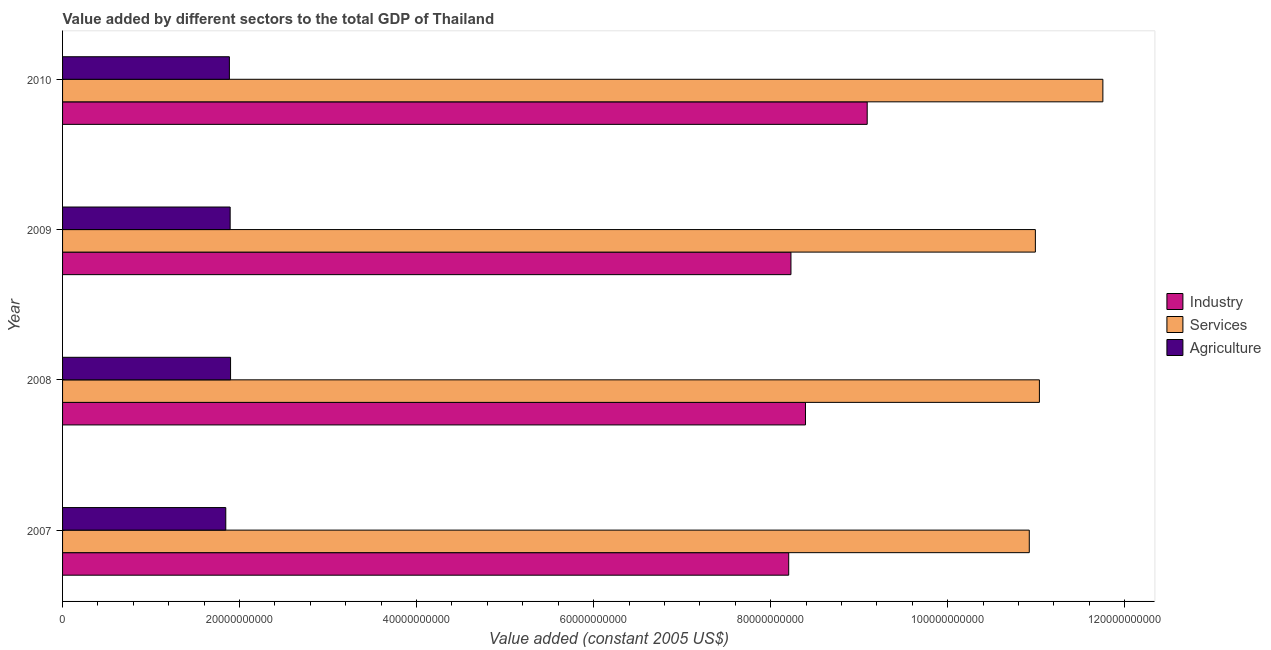How many groups of bars are there?
Keep it short and to the point. 4. What is the label of the 4th group of bars from the top?
Give a very brief answer. 2007. In how many cases, is the number of bars for a given year not equal to the number of legend labels?
Your answer should be compact. 0. What is the value added by services in 2009?
Your answer should be very brief. 1.10e+11. Across all years, what is the maximum value added by agricultural sector?
Your response must be concise. 1.90e+1. Across all years, what is the minimum value added by agricultural sector?
Provide a succinct answer. 1.84e+1. In which year was the value added by agricultural sector maximum?
Keep it short and to the point. 2008. What is the total value added by industrial sector in the graph?
Your answer should be compact. 3.39e+11. What is the difference between the value added by agricultural sector in 2007 and that in 2010?
Your response must be concise. -4.08e+08. What is the difference between the value added by services in 2007 and the value added by agricultural sector in 2008?
Give a very brief answer. 9.02e+1. What is the average value added by agricultural sector per year?
Offer a terse response. 1.88e+1. In the year 2009, what is the difference between the value added by agricultural sector and value added by services?
Your answer should be compact. -9.10e+1. In how many years, is the value added by agricultural sector greater than 116000000000 US$?
Make the answer very short. 0. What is the ratio of the value added by agricultural sector in 2008 to that in 2009?
Give a very brief answer. 1. Is the value added by services in 2008 less than that in 2010?
Keep it short and to the point. Yes. Is the difference between the value added by services in 2007 and 2008 greater than the difference between the value added by agricultural sector in 2007 and 2008?
Offer a terse response. No. What is the difference between the highest and the second highest value added by services?
Provide a succinct answer. 7.17e+09. What is the difference between the highest and the lowest value added by industrial sector?
Offer a very short reply. 8.87e+09. Is the sum of the value added by services in 2007 and 2009 greater than the maximum value added by agricultural sector across all years?
Provide a succinct answer. Yes. What does the 3rd bar from the top in 2009 represents?
Make the answer very short. Industry. What does the 2nd bar from the bottom in 2010 represents?
Your answer should be very brief. Services. Is it the case that in every year, the sum of the value added by industrial sector and value added by services is greater than the value added by agricultural sector?
Your answer should be compact. Yes. How many bars are there?
Offer a terse response. 12. What is the difference between two consecutive major ticks on the X-axis?
Ensure brevity in your answer.  2.00e+1. Are the values on the major ticks of X-axis written in scientific E-notation?
Make the answer very short. No. Does the graph contain any zero values?
Provide a short and direct response. No. Does the graph contain grids?
Your response must be concise. No. Where does the legend appear in the graph?
Offer a terse response. Center right. How are the legend labels stacked?
Make the answer very short. Vertical. What is the title of the graph?
Make the answer very short. Value added by different sectors to the total GDP of Thailand. What is the label or title of the X-axis?
Offer a terse response. Value added (constant 2005 US$). What is the Value added (constant 2005 US$) of Industry in 2007?
Your answer should be compact. 8.20e+1. What is the Value added (constant 2005 US$) in Services in 2007?
Your answer should be compact. 1.09e+11. What is the Value added (constant 2005 US$) in Agriculture in 2007?
Give a very brief answer. 1.84e+1. What is the Value added (constant 2005 US$) in Industry in 2008?
Your answer should be very brief. 8.39e+1. What is the Value added (constant 2005 US$) in Services in 2008?
Keep it short and to the point. 1.10e+11. What is the Value added (constant 2005 US$) in Agriculture in 2008?
Offer a terse response. 1.90e+1. What is the Value added (constant 2005 US$) of Industry in 2009?
Offer a very short reply. 8.23e+1. What is the Value added (constant 2005 US$) in Services in 2009?
Offer a terse response. 1.10e+11. What is the Value added (constant 2005 US$) in Agriculture in 2009?
Ensure brevity in your answer.  1.89e+1. What is the Value added (constant 2005 US$) of Industry in 2010?
Your response must be concise. 9.09e+1. What is the Value added (constant 2005 US$) in Services in 2010?
Ensure brevity in your answer.  1.18e+11. What is the Value added (constant 2005 US$) of Agriculture in 2010?
Your response must be concise. 1.88e+1. Across all years, what is the maximum Value added (constant 2005 US$) of Industry?
Offer a terse response. 9.09e+1. Across all years, what is the maximum Value added (constant 2005 US$) in Services?
Your response must be concise. 1.18e+11. Across all years, what is the maximum Value added (constant 2005 US$) in Agriculture?
Your answer should be very brief. 1.90e+1. Across all years, what is the minimum Value added (constant 2005 US$) of Industry?
Your response must be concise. 8.20e+1. Across all years, what is the minimum Value added (constant 2005 US$) in Services?
Offer a terse response. 1.09e+11. Across all years, what is the minimum Value added (constant 2005 US$) in Agriculture?
Make the answer very short. 1.84e+1. What is the total Value added (constant 2005 US$) of Industry in the graph?
Ensure brevity in your answer.  3.39e+11. What is the total Value added (constant 2005 US$) of Services in the graph?
Keep it short and to the point. 4.47e+11. What is the total Value added (constant 2005 US$) of Agriculture in the graph?
Give a very brief answer. 7.52e+1. What is the difference between the Value added (constant 2005 US$) of Industry in 2007 and that in 2008?
Your response must be concise. -1.90e+09. What is the difference between the Value added (constant 2005 US$) in Services in 2007 and that in 2008?
Offer a very short reply. -1.14e+09. What is the difference between the Value added (constant 2005 US$) of Agriculture in 2007 and that in 2008?
Your answer should be compact. -5.41e+08. What is the difference between the Value added (constant 2005 US$) in Industry in 2007 and that in 2009?
Provide a short and direct response. -2.54e+08. What is the difference between the Value added (constant 2005 US$) in Services in 2007 and that in 2009?
Ensure brevity in your answer.  -6.89e+08. What is the difference between the Value added (constant 2005 US$) of Agriculture in 2007 and that in 2009?
Give a very brief answer. -4.95e+08. What is the difference between the Value added (constant 2005 US$) of Industry in 2007 and that in 2010?
Give a very brief answer. -8.87e+09. What is the difference between the Value added (constant 2005 US$) in Services in 2007 and that in 2010?
Give a very brief answer. -8.32e+09. What is the difference between the Value added (constant 2005 US$) in Agriculture in 2007 and that in 2010?
Keep it short and to the point. -4.08e+08. What is the difference between the Value added (constant 2005 US$) in Industry in 2008 and that in 2009?
Keep it short and to the point. 1.64e+09. What is the difference between the Value added (constant 2005 US$) in Services in 2008 and that in 2009?
Keep it short and to the point. 4.55e+08. What is the difference between the Value added (constant 2005 US$) in Agriculture in 2008 and that in 2009?
Ensure brevity in your answer.  4.60e+07. What is the difference between the Value added (constant 2005 US$) in Industry in 2008 and that in 2010?
Make the answer very short. -6.97e+09. What is the difference between the Value added (constant 2005 US$) in Services in 2008 and that in 2010?
Offer a terse response. -7.17e+09. What is the difference between the Value added (constant 2005 US$) in Agriculture in 2008 and that in 2010?
Offer a very short reply. 1.33e+08. What is the difference between the Value added (constant 2005 US$) in Industry in 2009 and that in 2010?
Offer a very short reply. -8.62e+09. What is the difference between the Value added (constant 2005 US$) in Services in 2009 and that in 2010?
Your answer should be compact. -7.63e+09. What is the difference between the Value added (constant 2005 US$) of Agriculture in 2009 and that in 2010?
Your answer should be very brief. 8.66e+07. What is the difference between the Value added (constant 2005 US$) of Industry in 2007 and the Value added (constant 2005 US$) of Services in 2008?
Your answer should be very brief. -2.83e+1. What is the difference between the Value added (constant 2005 US$) of Industry in 2007 and the Value added (constant 2005 US$) of Agriculture in 2008?
Provide a succinct answer. 6.31e+1. What is the difference between the Value added (constant 2005 US$) in Services in 2007 and the Value added (constant 2005 US$) in Agriculture in 2008?
Your answer should be very brief. 9.02e+1. What is the difference between the Value added (constant 2005 US$) in Industry in 2007 and the Value added (constant 2005 US$) in Services in 2009?
Provide a short and direct response. -2.79e+1. What is the difference between the Value added (constant 2005 US$) of Industry in 2007 and the Value added (constant 2005 US$) of Agriculture in 2009?
Offer a very short reply. 6.31e+1. What is the difference between the Value added (constant 2005 US$) in Services in 2007 and the Value added (constant 2005 US$) in Agriculture in 2009?
Make the answer very short. 9.03e+1. What is the difference between the Value added (constant 2005 US$) of Industry in 2007 and the Value added (constant 2005 US$) of Services in 2010?
Ensure brevity in your answer.  -3.55e+1. What is the difference between the Value added (constant 2005 US$) in Industry in 2007 and the Value added (constant 2005 US$) in Agriculture in 2010?
Provide a short and direct response. 6.32e+1. What is the difference between the Value added (constant 2005 US$) in Services in 2007 and the Value added (constant 2005 US$) in Agriculture in 2010?
Your answer should be very brief. 9.04e+1. What is the difference between the Value added (constant 2005 US$) in Industry in 2008 and the Value added (constant 2005 US$) in Services in 2009?
Provide a succinct answer. -2.60e+1. What is the difference between the Value added (constant 2005 US$) of Industry in 2008 and the Value added (constant 2005 US$) of Agriculture in 2009?
Give a very brief answer. 6.50e+1. What is the difference between the Value added (constant 2005 US$) in Services in 2008 and the Value added (constant 2005 US$) in Agriculture in 2009?
Your answer should be very brief. 9.14e+1. What is the difference between the Value added (constant 2005 US$) in Industry in 2008 and the Value added (constant 2005 US$) in Services in 2010?
Make the answer very short. -3.36e+1. What is the difference between the Value added (constant 2005 US$) of Industry in 2008 and the Value added (constant 2005 US$) of Agriculture in 2010?
Offer a very short reply. 6.51e+1. What is the difference between the Value added (constant 2005 US$) of Services in 2008 and the Value added (constant 2005 US$) of Agriculture in 2010?
Your answer should be very brief. 9.15e+1. What is the difference between the Value added (constant 2005 US$) in Industry in 2009 and the Value added (constant 2005 US$) in Services in 2010?
Your answer should be compact. -3.52e+1. What is the difference between the Value added (constant 2005 US$) of Industry in 2009 and the Value added (constant 2005 US$) of Agriculture in 2010?
Your answer should be very brief. 6.34e+1. What is the difference between the Value added (constant 2005 US$) in Services in 2009 and the Value added (constant 2005 US$) in Agriculture in 2010?
Ensure brevity in your answer.  9.11e+1. What is the average Value added (constant 2005 US$) of Industry per year?
Provide a short and direct response. 8.48e+1. What is the average Value added (constant 2005 US$) of Services per year?
Your response must be concise. 1.12e+11. What is the average Value added (constant 2005 US$) in Agriculture per year?
Offer a terse response. 1.88e+1. In the year 2007, what is the difference between the Value added (constant 2005 US$) of Industry and Value added (constant 2005 US$) of Services?
Provide a short and direct response. -2.72e+1. In the year 2007, what is the difference between the Value added (constant 2005 US$) of Industry and Value added (constant 2005 US$) of Agriculture?
Your answer should be compact. 6.36e+1. In the year 2007, what is the difference between the Value added (constant 2005 US$) in Services and Value added (constant 2005 US$) in Agriculture?
Your answer should be very brief. 9.08e+1. In the year 2008, what is the difference between the Value added (constant 2005 US$) in Industry and Value added (constant 2005 US$) in Services?
Make the answer very short. -2.64e+1. In the year 2008, what is the difference between the Value added (constant 2005 US$) of Industry and Value added (constant 2005 US$) of Agriculture?
Offer a very short reply. 6.50e+1. In the year 2008, what is the difference between the Value added (constant 2005 US$) of Services and Value added (constant 2005 US$) of Agriculture?
Your response must be concise. 9.14e+1. In the year 2009, what is the difference between the Value added (constant 2005 US$) of Industry and Value added (constant 2005 US$) of Services?
Your answer should be very brief. -2.76e+1. In the year 2009, what is the difference between the Value added (constant 2005 US$) in Industry and Value added (constant 2005 US$) in Agriculture?
Your answer should be compact. 6.34e+1. In the year 2009, what is the difference between the Value added (constant 2005 US$) of Services and Value added (constant 2005 US$) of Agriculture?
Offer a terse response. 9.10e+1. In the year 2010, what is the difference between the Value added (constant 2005 US$) in Industry and Value added (constant 2005 US$) in Services?
Offer a terse response. -2.66e+1. In the year 2010, what is the difference between the Value added (constant 2005 US$) in Industry and Value added (constant 2005 US$) in Agriculture?
Make the answer very short. 7.21e+1. In the year 2010, what is the difference between the Value added (constant 2005 US$) in Services and Value added (constant 2005 US$) in Agriculture?
Provide a succinct answer. 9.87e+1. What is the ratio of the Value added (constant 2005 US$) in Industry in 2007 to that in 2008?
Keep it short and to the point. 0.98. What is the ratio of the Value added (constant 2005 US$) of Agriculture in 2007 to that in 2008?
Make the answer very short. 0.97. What is the ratio of the Value added (constant 2005 US$) in Industry in 2007 to that in 2009?
Provide a succinct answer. 1. What is the ratio of the Value added (constant 2005 US$) of Services in 2007 to that in 2009?
Your response must be concise. 0.99. What is the ratio of the Value added (constant 2005 US$) in Agriculture in 2007 to that in 2009?
Keep it short and to the point. 0.97. What is the ratio of the Value added (constant 2005 US$) of Industry in 2007 to that in 2010?
Your answer should be very brief. 0.9. What is the ratio of the Value added (constant 2005 US$) of Services in 2007 to that in 2010?
Offer a very short reply. 0.93. What is the ratio of the Value added (constant 2005 US$) of Agriculture in 2007 to that in 2010?
Offer a terse response. 0.98. What is the ratio of the Value added (constant 2005 US$) of Industry in 2008 to that in 2009?
Your response must be concise. 1.02. What is the ratio of the Value added (constant 2005 US$) of Agriculture in 2008 to that in 2009?
Provide a short and direct response. 1. What is the ratio of the Value added (constant 2005 US$) of Industry in 2008 to that in 2010?
Give a very brief answer. 0.92. What is the ratio of the Value added (constant 2005 US$) in Services in 2008 to that in 2010?
Your answer should be compact. 0.94. What is the ratio of the Value added (constant 2005 US$) of Agriculture in 2008 to that in 2010?
Your answer should be compact. 1.01. What is the ratio of the Value added (constant 2005 US$) in Industry in 2009 to that in 2010?
Give a very brief answer. 0.91. What is the ratio of the Value added (constant 2005 US$) in Services in 2009 to that in 2010?
Make the answer very short. 0.94. What is the difference between the highest and the second highest Value added (constant 2005 US$) in Industry?
Your answer should be compact. 6.97e+09. What is the difference between the highest and the second highest Value added (constant 2005 US$) in Services?
Provide a short and direct response. 7.17e+09. What is the difference between the highest and the second highest Value added (constant 2005 US$) in Agriculture?
Provide a succinct answer. 4.60e+07. What is the difference between the highest and the lowest Value added (constant 2005 US$) in Industry?
Ensure brevity in your answer.  8.87e+09. What is the difference between the highest and the lowest Value added (constant 2005 US$) of Services?
Your answer should be compact. 8.32e+09. What is the difference between the highest and the lowest Value added (constant 2005 US$) in Agriculture?
Give a very brief answer. 5.41e+08. 